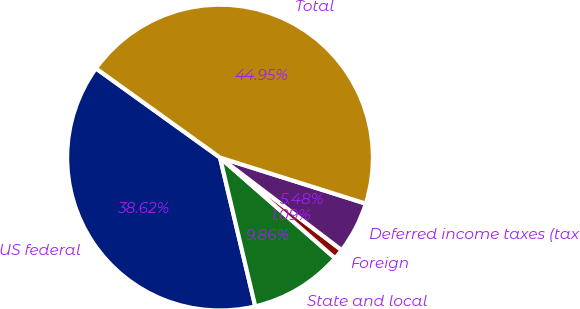Convert chart. <chart><loc_0><loc_0><loc_500><loc_500><pie_chart><fcel>US federal<fcel>State and local<fcel>Foreign<fcel>Deferred income taxes (tax<fcel>Total<nl><fcel>38.62%<fcel>9.86%<fcel>1.09%<fcel>5.48%<fcel>44.95%<nl></chart> 